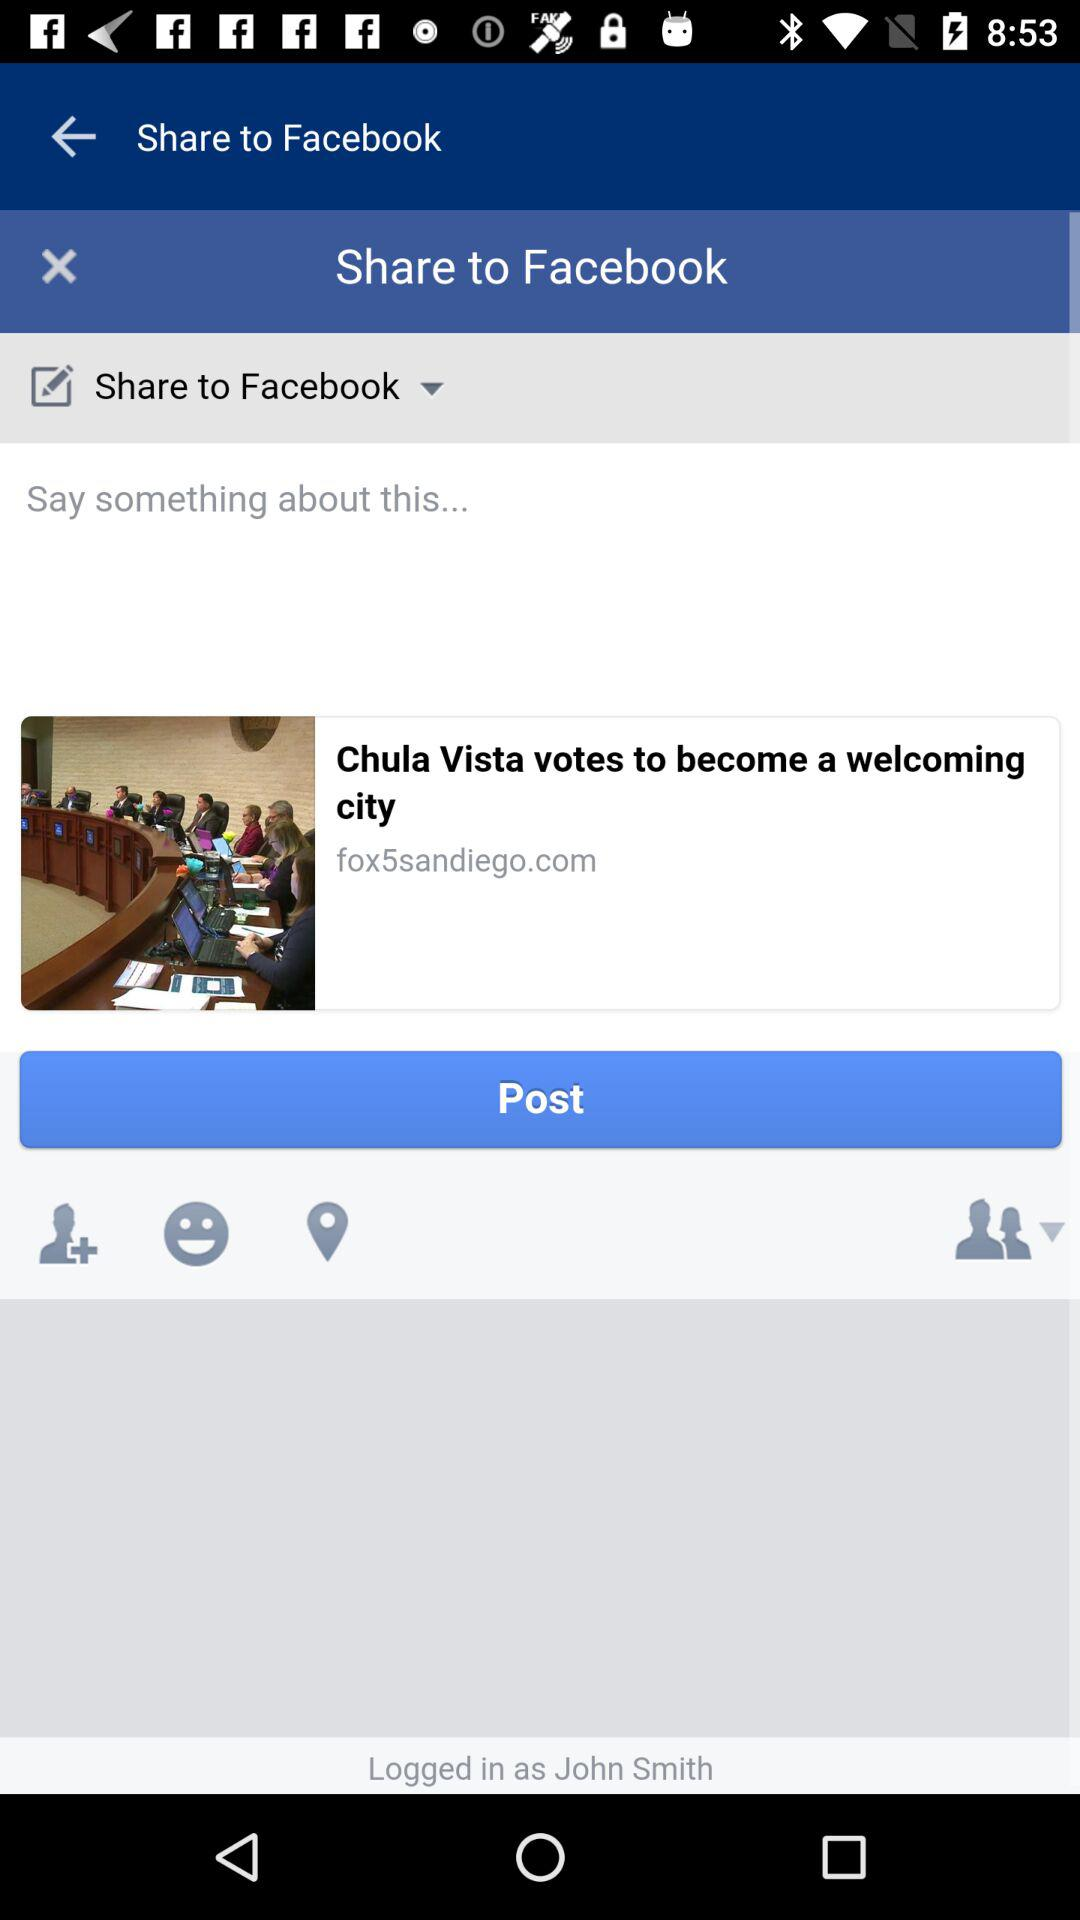What is the login name? The login name is John Smith. 